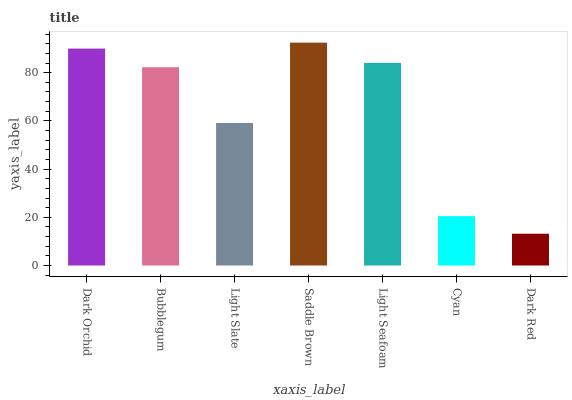Is Dark Red the minimum?
Answer yes or no. Yes. Is Saddle Brown the maximum?
Answer yes or no. Yes. Is Bubblegum the minimum?
Answer yes or no. No. Is Bubblegum the maximum?
Answer yes or no. No. Is Dark Orchid greater than Bubblegum?
Answer yes or no. Yes. Is Bubblegum less than Dark Orchid?
Answer yes or no. Yes. Is Bubblegum greater than Dark Orchid?
Answer yes or no. No. Is Dark Orchid less than Bubblegum?
Answer yes or no. No. Is Bubblegum the high median?
Answer yes or no. Yes. Is Bubblegum the low median?
Answer yes or no. Yes. Is Saddle Brown the high median?
Answer yes or no. No. Is Dark Orchid the low median?
Answer yes or no. No. 